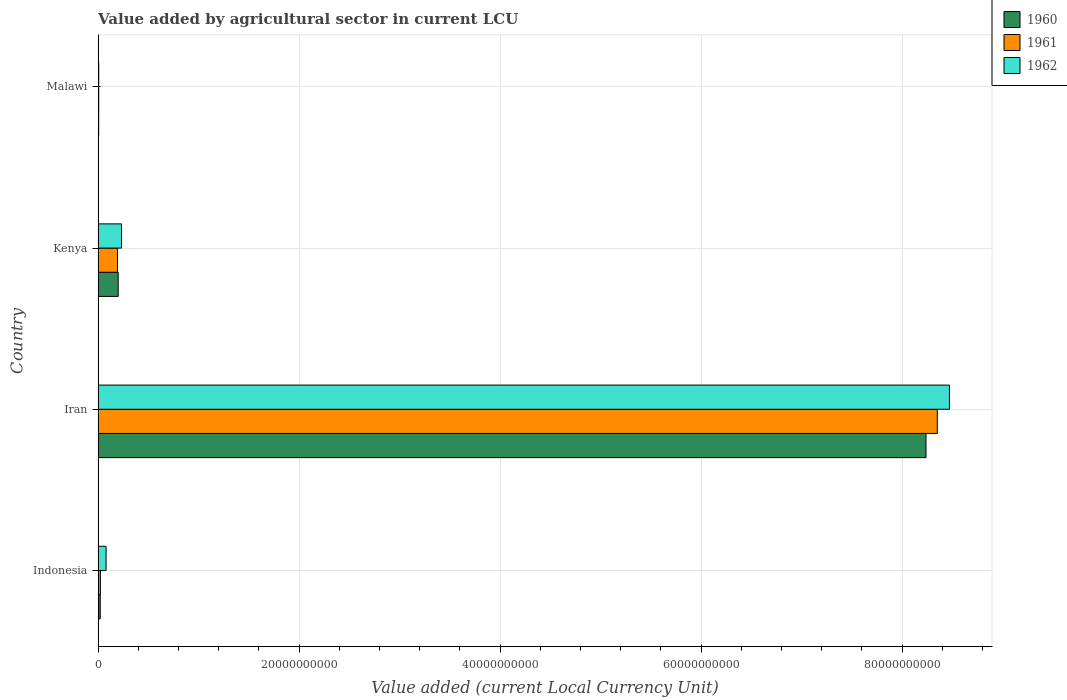How many groups of bars are there?
Keep it short and to the point. 4. Are the number of bars on each tick of the Y-axis equal?
Offer a terse response. Yes. How many bars are there on the 2nd tick from the top?
Your answer should be compact. 3. What is the label of the 3rd group of bars from the top?
Make the answer very short. Iran. What is the value added by agricultural sector in 1961 in Kenya?
Your answer should be very brief. 1.93e+09. Across all countries, what is the maximum value added by agricultural sector in 1962?
Make the answer very short. 8.47e+1. Across all countries, what is the minimum value added by agricultural sector in 1960?
Offer a very short reply. 5.63e+07. In which country was the value added by agricultural sector in 1962 maximum?
Provide a succinct answer. Iran. In which country was the value added by agricultural sector in 1962 minimum?
Ensure brevity in your answer.  Malawi. What is the total value added by agricultural sector in 1961 in the graph?
Make the answer very short. 8.57e+1. What is the difference between the value added by agricultural sector in 1960 in Indonesia and that in Iran?
Give a very brief answer. -8.22e+1. What is the difference between the value added by agricultural sector in 1961 in Malawi and the value added by agricultural sector in 1962 in Indonesia?
Ensure brevity in your answer.  -7.32e+08. What is the average value added by agricultural sector in 1960 per country?
Keep it short and to the point. 2.12e+1. What is the difference between the value added by agricultural sector in 1960 and value added by agricultural sector in 1962 in Indonesia?
Provide a succinct answer. -5.81e+08. In how many countries, is the value added by agricultural sector in 1960 greater than 12000000000 LCU?
Ensure brevity in your answer.  1. What is the ratio of the value added by agricultural sector in 1961 in Indonesia to that in Malawi?
Make the answer very short. 3.75. Is the value added by agricultural sector in 1961 in Iran less than that in Malawi?
Provide a succinct answer. No. What is the difference between the highest and the second highest value added by agricultural sector in 1961?
Your answer should be compact. 8.16e+1. What is the difference between the highest and the lowest value added by agricultural sector in 1962?
Offer a very short reply. 8.47e+1. Is the sum of the value added by agricultural sector in 1960 in Iran and Kenya greater than the maximum value added by agricultural sector in 1961 across all countries?
Ensure brevity in your answer.  Yes. How many countries are there in the graph?
Offer a very short reply. 4. Does the graph contain any zero values?
Your answer should be very brief. No. How many legend labels are there?
Provide a succinct answer. 3. How are the legend labels stacked?
Provide a succinct answer. Vertical. What is the title of the graph?
Make the answer very short. Value added by agricultural sector in current LCU. What is the label or title of the X-axis?
Your response must be concise. Value added (current Local Currency Unit). What is the Value added (current Local Currency Unit) in 1960 in Indonesia?
Keep it short and to the point. 2.12e+08. What is the Value added (current Local Currency Unit) in 1961 in Indonesia?
Give a very brief answer. 2.27e+08. What is the Value added (current Local Currency Unit) of 1962 in Indonesia?
Offer a terse response. 7.93e+08. What is the Value added (current Local Currency Unit) in 1960 in Iran?
Offer a very short reply. 8.24e+1. What is the Value added (current Local Currency Unit) of 1961 in Iran?
Provide a succinct answer. 8.35e+1. What is the Value added (current Local Currency Unit) in 1962 in Iran?
Offer a terse response. 8.47e+1. What is the Value added (current Local Currency Unit) in 1960 in Kenya?
Provide a succinct answer. 2.00e+09. What is the Value added (current Local Currency Unit) in 1961 in Kenya?
Keep it short and to the point. 1.93e+09. What is the Value added (current Local Currency Unit) in 1962 in Kenya?
Give a very brief answer. 2.33e+09. What is the Value added (current Local Currency Unit) of 1960 in Malawi?
Give a very brief answer. 5.63e+07. What is the Value added (current Local Currency Unit) of 1961 in Malawi?
Provide a short and direct response. 6.06e+07. What is the Value added (current Local Currency Unit) of 1962 in Malawi?
Your answer should be very brief. 6.36e+07. Across all countries, what is the maximum Value added (current Local Currency Unit) in 1960?
Your answer should be very brief. 8.24e+1. Across all countries, what is the maximum Value added (current Local Currency Unit) of 1961?
Your answer should be very brief. 8.35e+1. Across all countries, what is the maximum Value added (current Local Currency Unit) in 1962?
Your answer should be compact. 8.47e+1. Across all countries, what is the minimum Value added (current Local Currency Unit) in 1960?
Your answer should be very brief. 5.63e+07. Across all countries, what is the minimum Value added (current Local Currency Unit) of 1961?
Your response must be concise. 6.06e+07. Across all countries, what is the minimum Value added (current Local Currency Unit) of 1962?
Your answer should be very brief. 6.36e+07. What is the total Value added (current Local Currency Unit) of 1960 in the graph?
Provide a succinct answer. 8.47e+1. What is the total Value added (current Local Currency Unit) of 1961 in the graph?
Make the answer very short. 8.57e+1. What is the total Value added (current Local Currency Unit) of 1962 in the graph?
Ensure brevity in your answer.  8.79e+1. What is the difference between the Value added (current Local Currency Unit) in 1960 in Indonesia and that in Iran?
Make the answer very short. -8.22e+1. What is the difference between the Value added (current Local Currency Unit) in 1961 in Indonesia and that in Iran?
Your response must be concise. -8.33e+1. What is the difference between the Value added (current Local Currency Unit) in 1962 in Indonesia and that in Iran?
Your response must be concise. -8.39e+1. What is the difference between the Value added (current Local Currency Unit) in 1960 in Indonesia and that in Kenya?
Your answer should be compact. -1.79e+09. What is the difference between the Value added (current Local Currency Unit) of 1961 in Indonesia and that in Kenya?
Give a very brief answer. -1.70e+09. What is the difference between the Value added (current Local Currency Unit) in 1962 in Indonesia and that in Kenya?
Ensure brevity in your answer.  -1.54e+09. What is the difference between the Value added (current Local Currency Unit) in 1960 in Indonesia and that in Malawi?
Keep it short and to the point. 1.56e+08. What is the difference between the Value added (current Local Currency Unit) in 1961 in Indonesia and that in Malawi?
Ensure brevity in your answer.  1.66e+08. What is the difference between the Value added (current Local Currency Unit) in 1962 in Indonesia and that in Malawi?
Keep it short and to the point. 7.29e+08. What is the difference between the Value added (current Local Currency Unit) in 1960 in Iran and that in Kenya?
Keep it short and to the point. 8.04e+1. What is the difference between the Value added (current Local Currency Unit) in 1961 in Iran and that in Kenya?
Provide a short and direct response. 8.16e+1. What is the difference between the Value added (current Local Currency Unit) of 1962 in Iran and that in Kenya?
Keep it short and to the point. 8.24e+1. What is the difference between the Value added (current Local Currency Unit) of 1960 in Iran and that in Malawi?
Your answer should be compact. 8.23e+1. What is the difference between the Value added (current Local Currency Unit) in 1961 in Iran and that in Malawi?
Your answer should be compact. 8.34e+1. What is the difference between the Value added (current Local Currency Unit) in 1962 in Iran and that in Malawi?
Give a very brief answer. 8.47e+1. What is the difference between the Value added (current Local Currency Unit) of 1960 in Kenya and that in Malawi?
Keep it short and to the point. 1.94e+09. What is the difference between the Value added (current Local Currency Unit) of 1961 in Kenya and that in Malawi?
Offer a terse response. 1.87e+09. What is the difference between the Value added (current Local Currency Unit) of 1962 in Kenya and that in Malawi?
Make the answer very short. 2.27e+09. What is the difference between the Value added (current Local Currency Unit) in 1960 in Indonesia and the Value added (current Local Currency Unit) in 1961 in Iran?
Make the answer very short. -8.33e+1. What is the difference between the Value added (current Local Currency Unit) of 1960 in Indonesia and the Value added (current Local Currency Unit) of 1962 in Iran?
Make the answer very short. -8.45e+1. What is the difference between the Value added (current Local Currency Unit) of 1961 in Indonesia and the Value added (current Local Currency Unit) of 1962 in Iran?
Provide a succinct answer. -8.45e+1. What is the difference between the Value added (current Local Currency Unit) in 1960 in Indonesia and the Value added (current Local Currency Unit) in 1961 in Kenya?
Ensure brevity in your answer.  -1.72e+09. What is the difference between the Value added (current Local Currency Unit) of 1960 in Indonesia and the Value added (current Local Currency Unit) of 1962 in Kenya?
Ensure brevity in your answer.  -2.12e+09. What is the difference between the Value added (current Local Currency Unit) in 1961 in Indonesia and the Value added (current Local Currency Unit) in 1962 in Kenya?
Your answer should be compact. -2.10e+09. What is the difference between the Value added (current Local Currency Unit) in 1960 in Indonesia and the Value added (current Local Currency Unit) in 1961 in Malawi?
Your answer should be compact. 1.51e+08. What is the difference between the Value added (current Local Currency Unit) of 1960 in Indonesia and the Value added (current Local Currency Unit) of 1962 in Malawi?
Your answer should be compact. 1.48e+08. What is the difference between the Value added (current Local Currency Unit) of 1961 in Indonesia and the Value added (current Local Currency Unit) of 1962 in Malawi?
Give a very brief answer. 1.63e+08. What is the difference between the Value added (current Local Currency Unit) of 1960 in Iran and the Value added (current Local Currency Unit) of 1961 in Kenya?
Your response must be concise. 8.05e+1. What is the difference between the Value added (current Local Currency Unit) in 1960 in Iran and the Value added (current Local Currency Unit) in 1962 in Kenya?
Give a very brief answer. 8.01e+1. What is the difference between the Value added (current Local Currency Unit) of 1961 in Iran and the Value added (current Local Currency Unit) of 1962 in Kenya?
Offer a very short reply. 8.12e+1. What is the difference between the Value added (current Local Currency Unit) in 1960 in Iran and the Value added (current Local Currency Unit) in 1961 in Malawi?
Your response must be concise. 8.23e+1. What is the difference between the Value added (current Local Currency Unit) in 1960 in Iran and the Value added (current Local Currency Unit) in 1962 in Malawi?
Offer a terse response. 8.23e+1. What is the difference between the Value added (current Local Currency Unit) in 1961 in Iran and the Value added (current Local Currency Unit) in 1962 in Malawi?
Provide a short and direct response. 8.34e+1. What is the difference between the Value added (current Local Currency Unit) of 1960 in Kenya and the Value added (current Local Currency Unit) of 1961 in Malawi?
Your response must be concise. 1.94e+09. What is the difference between the Value added (current Local Currency Unit) of 1960 in Kenya and the Value added (current Local Currency Unit) of 1962 in Malawi?
Ensure brevity in your answer.  1.93e+09. What is the difference between the Value added (current Local Currency Unit) in 1961 in Kenya and the Value added (current Local Currency Unit) in 1962 in Malawi?
Your answer should be very brief. 1.87e+09. What is the average Value added (current Local Currency Unit) of 1960 per country?
Give a very brief answer. 2.12e+1. What is the average Value added (current Local Currency Unit) of 1961 per country?
Offer a very short reply. 2.14e+1. What is the average Value added (current Local Currency Unit) of 1962 per country?
Make the answer very short. 2.20e+1. What is the difference between the Value added (current Local Currency Unit) of 1960 and Value added (current Local Currency Unit) of 1961 in Indonesia?
Offer a terse response. -1.50e+07. What is the difference between the Value added (current Local Currency Unit) in 1960 and Value added (current Local Currency Unit) in 1962 in Indonesia?
Your answer should be very brief. -5.81e+08. What is the difference between the Value added (current Local Currency Unit) in 1961 and Value added (current Local Currency Unit) in 1962 in Indonesia?
Keep it short and to the point. -5.66e+08. What is the difference between the Value added (current Local Currency Unit) of 1960 and Value added (current Local Currency Unit) of 1961 in Iran?
Keep it short and to the point. -1.12e+09. What is the difference between the Value added (current Local Currency Unit) in 1960 and Value added (current Local Currency Unit) in 1962 in Iran?
Keep it short and to the point. -2.33e+09. What is the difference between the Value added (current Local Currency Unit) in 1961 and Value added (current Local Currency Unit) in 1962 in Iran?
Provide a short and direct response. -1.21e+09. What is the difference between the Value added (current Local Currency Unit) of 1960 and Value added (current Local Currency Unit) of 1961 in Kenya?
Provide a short and direct response. 6.79e+07. What is the difference between the Value added (current Local Currency Unit) in 1960 and Value added (current Local Currency Unit) in 1962 in Kenya?
Make the answer very short. -3.32e+08. What is the difference between the Value added (current Local Currency Unit) in 1961 and Value added (current Local Currency Unit) in 1962 in Kenya?
Offer a terse response. -4.00e+08. What is the difference between the Value added (current Local Currency Unit) in 1960 and Value added (current Local Currency Unit) in 1961 in Malawi?
Your answer should be compact. -4.30e+06. What is the difference between the Value added (current Local Currency Unit) of 1960 and Value added (current Local Currency Unit) of 1962 in Malawi?
Ensure brevity in your answer.  -7.30e+06. What is the ratio of the Value added (current Local Currency Unit) in 1960 in Indonesia to that in Iran?
Your answer should be very brief. 0. What is the ratio of the Value added (current Local Currency Unit) in 1961 in Indonesia to that in Iran?
Provide a succinct answer. 0. What is the ratio of the Value added (current Local Currency Unit) in 1962 in Indonesia to that in Iran?
Give a very brief answer. 0.01. What is the ratio of the Value added (current Local Currency Unit) of 1960 in Indonesia to that in Kenya?
Keep it short and to the point. 0.11. What is the ratio of the Value added (current Local Currency Unit) in 1961 in Indonesia to that in Kenya?
Ensure brevity in your answer.  0.12. What is the ratio of the Value added (current Local Currency Unit) of 1962 in Indonesia to that in Kenya?
Your answer should be compact. 0.34. What is the ratio of the Value added (current Local Currency Unit) in 1960 in Indonesia to that in Malawi?
Give a very brief answer. 3.77. What is the ratio of the Value added (current Local Currency Unit) in 1961 in Indonesia to that in Malawi?
Ensure brevity in your answer.  3.75. What is the ratio of the Value added (current Local Currency Unit) in 1962 in Indonesia to that in Malawi?
Your response must be concise. 12.47. What is the ratio of the Value added (current Local Currency Unit) of 1960 in Iran to that in Kenya?
Ensure brevity in your answer.  41.24. What is the ratio of the Value added (current Local Currency Unit) of 1961 in Iran to that in Kenya?
Your response must be concise. 43.27. What is the ratio of the Value added (current Local Currency Unit) in 1962 in Iran to that in Kenya?
Make the answer very short. 36.36. What is the ratio of the Value added (current Local Currency Unit) in 1960 in Iran to that in Malawi?
Make the answer very short. 1463.34. What is the ratio of the Value added (current Local Currency Unit) of 1961 in Iran to that in Malawi?
Offer a terse response. 1378.03. What is the ratio of the Value added (current Local Currency Unit) of 1962 in Iran to that in Malawi?
Provide a short and direct response. 1332.01. What is the ratio of the Value added (current Local Currency Unit) of 1960 in Kenya to that in Malawi?
Provide a succinct answer. 35.48. What is the ratio of the Value added (current Local Currency Unit) in 1961 in Kenya to that in Malawi?
Your answer should be very brief. 31.85. What is the ratio of the Value added (current Local Currency Unit) in 1962 in Kenya to that in Malawi?
Offer a very short reply. 36.63. What is the difference between the highest and the second highest Value added (current Local Currency Unit) in 1960?
Offer a terse response. 8.04e+1. What is the difference between the highest and the second highest Value added (current Local Currency Unit) of 1961?
Give a very brief answer. 8.16e+1. What is the difference between the highest and the second highest Value added (current Local Currency Unit) in 1962?
Offer a very short reply. 8.24e+1. What is the difference between the highest and the lowest Value added (current Local Currency Unit) in 1960?
Provide a short and direct response. 8.23e+1. What is the difference between the highest and the lowest Value added (current Local Currency Unit) of 1961?
Keep it short and to the point. 8.34e+1. What is the difference between the highest and the lowest Value added (current Local Currency Unit) of 1962?
Make the answer very short. 8.47e+1. 